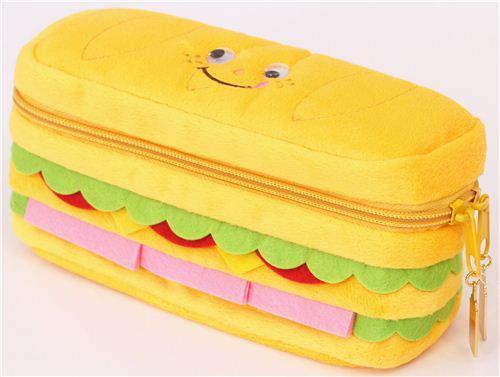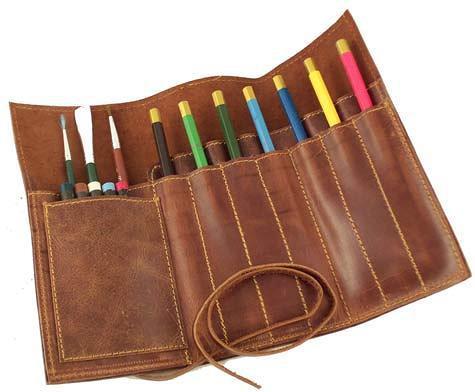The first image is the image on the left, the second image is the image on the right. Evaluate the accuracy of this statement regarding the images: "the case in the image on the left is open". Is it true? Answer yes or no. No. The first image is the image on the left, the second image is the image on the right. Given the left and right images, does the statement "There is at least one open wooden pencil case." hold true? Answer yes or no. No. 